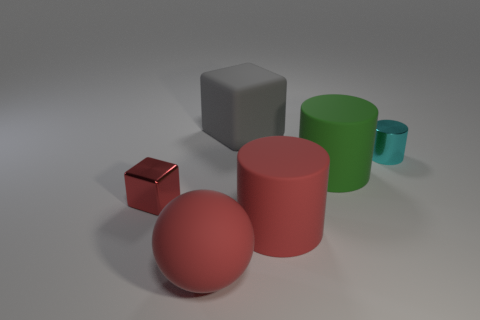Are there any spheres that have the same material as the small block?
Offer a terse response. No. Is the number of small red metal cubes behind the cyan thing less than the number of tiny red blocks?
Ensure brevity in your answer.  Yes. What is the material of the big red object on the left side of the big matte object behind the tiny metallic cylinder?
Make the answer very short. Rubber. The thing that is both left of the cyan shiny object and behind the large green matte cylinder has what shape?
Your response must be concise. Cube. How many other objects are the same color as the small cylinder?
Offer a terse response. 0. How many objects are large matte things that are right of the large ball or purple rubber objects?
Your answer should be compact. 3. Do the large rubber block and the tiny shiny object to the left of the tiny cyan metal cylinder have the same color?
Your answer should be compact. No. Is there any other thing that is the same size as the sphere?
Ensure brevity in your answer.  Yes. There is a red object behind the cylinder that is in front of the large green matte object; what size is it?
Your answer should be compact. Small. What number of objects are either gray blocks or red metal objects that are on the left side of the big gray rubber cube?
Provide a succinct answer. 2. 